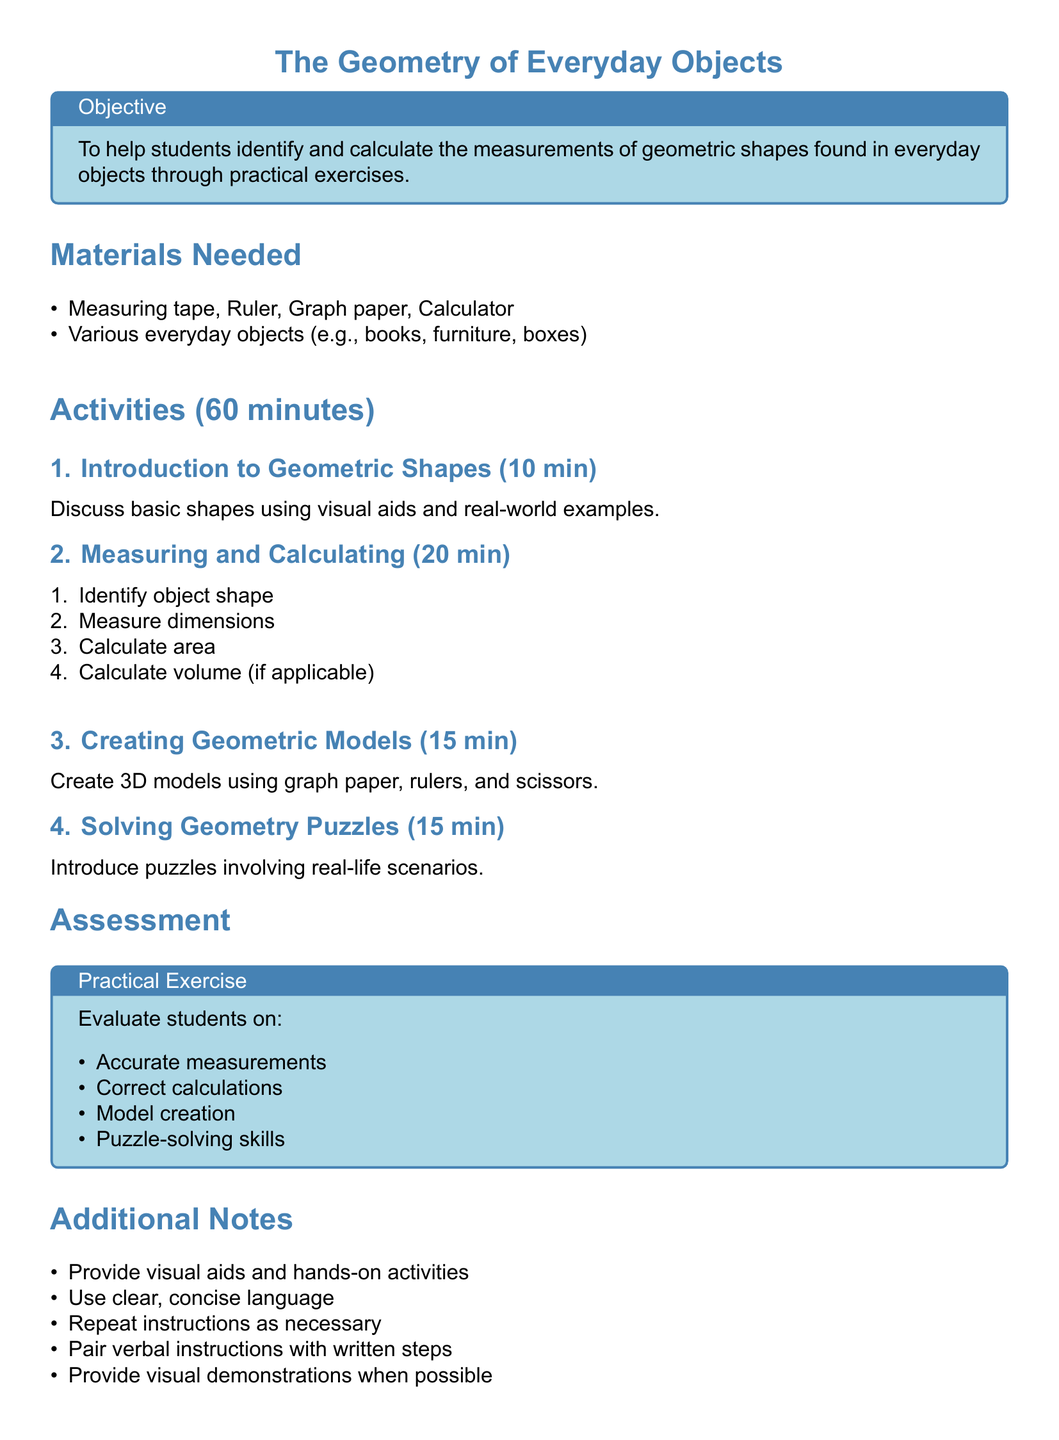What is the title of the lesson? The title is the main heading of the document and indicates the focus of the lesson.
Answer: The Geometry of Everyday Objects How long is the total duration of the activities? The total duration is mentioned in the activities section of the lesson plan and is summed up as 60 minutes.
Answer: 60 minutes What materials are needed for the lesson? The materials section lists the items required for the lesson activities.
Answer: Measuring tape, Ruler, Graph paper, Calculator What is the first activity in the lesson plan? The first activity is itemized in the activities section and describes the introduction to shapes.
Answer: Introduction to Geometric Shapes How many minutes are allocated to creating geometric models? The duration for creating models is specified in the activities section.
Answer: 15 minutes What is one method of assessment mentioned in the lesson plan? The assessment section outlines how students will be evaluated based on their performance in certain tasks.
Answer: Practical Exercise What should be paired with verbal instructions according to the additional notes? The additional notes provide suggestions for effective teaching strategies to support students.
Answer: Written steps How many minutes are dedicated to solving geometry puzzles? The time allocated is detailed in the activities section of the document.
Answer: 15 minutes What shape-related calculation is included in the measuring and calculating activity? The activity outlines specific calculations students need to perform with measurements.
Answer: Area 